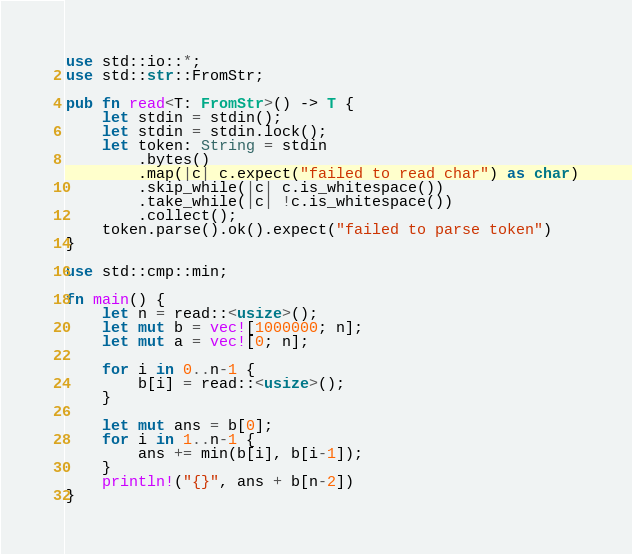Convert code to text. <code><loc_0><loc_0><loc_500><loc_500><_Rust_>use std::io::*;
use std::str::FromStr;

pub fn read<T: FromStr>() -> T {
    let stdin = stdin();
    let stdin = stdin.lock();
    let token: String = stdin
        .bytes()
        .map(|c| c.expect("failed to read char") as char)
        .skip_while(|c| c.is_whitespace())
        .take_while(|c| !c.is_whitespace())
        .collect();
    token.parse().ok().expect("failed to parse token")
}

use std::cmp::min;

fn main() {
    let n = read::<usize>();
    let mut b = vec![1000000; n];
    let mut a = vec![0; n];

    for i in 0..n-1 {
        b[i] = read::<usize>();
    }

    let mut ans = b[0];
    for i in 1..n-1 {
        ans += min(b[i], b[i-1]);
    }
    println!("{}", ans + b[n-2])
}</code> 